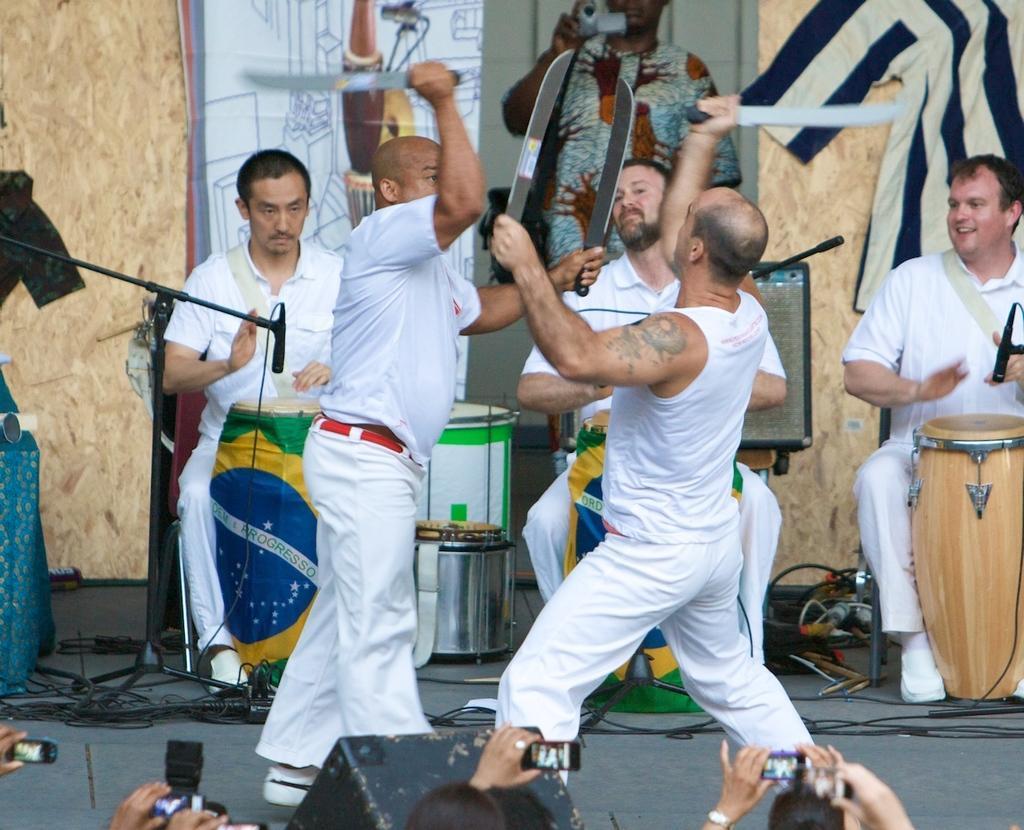Please provide a concise description of this image. In this image I can see two men are fighting with swords. In the background three men are sitting on the chairs and playing the drums. On the bottom of the image I can see few people are holding cameras, mobiles in hands and capturing it. In the background there is a person standing holding the camera in hand. 